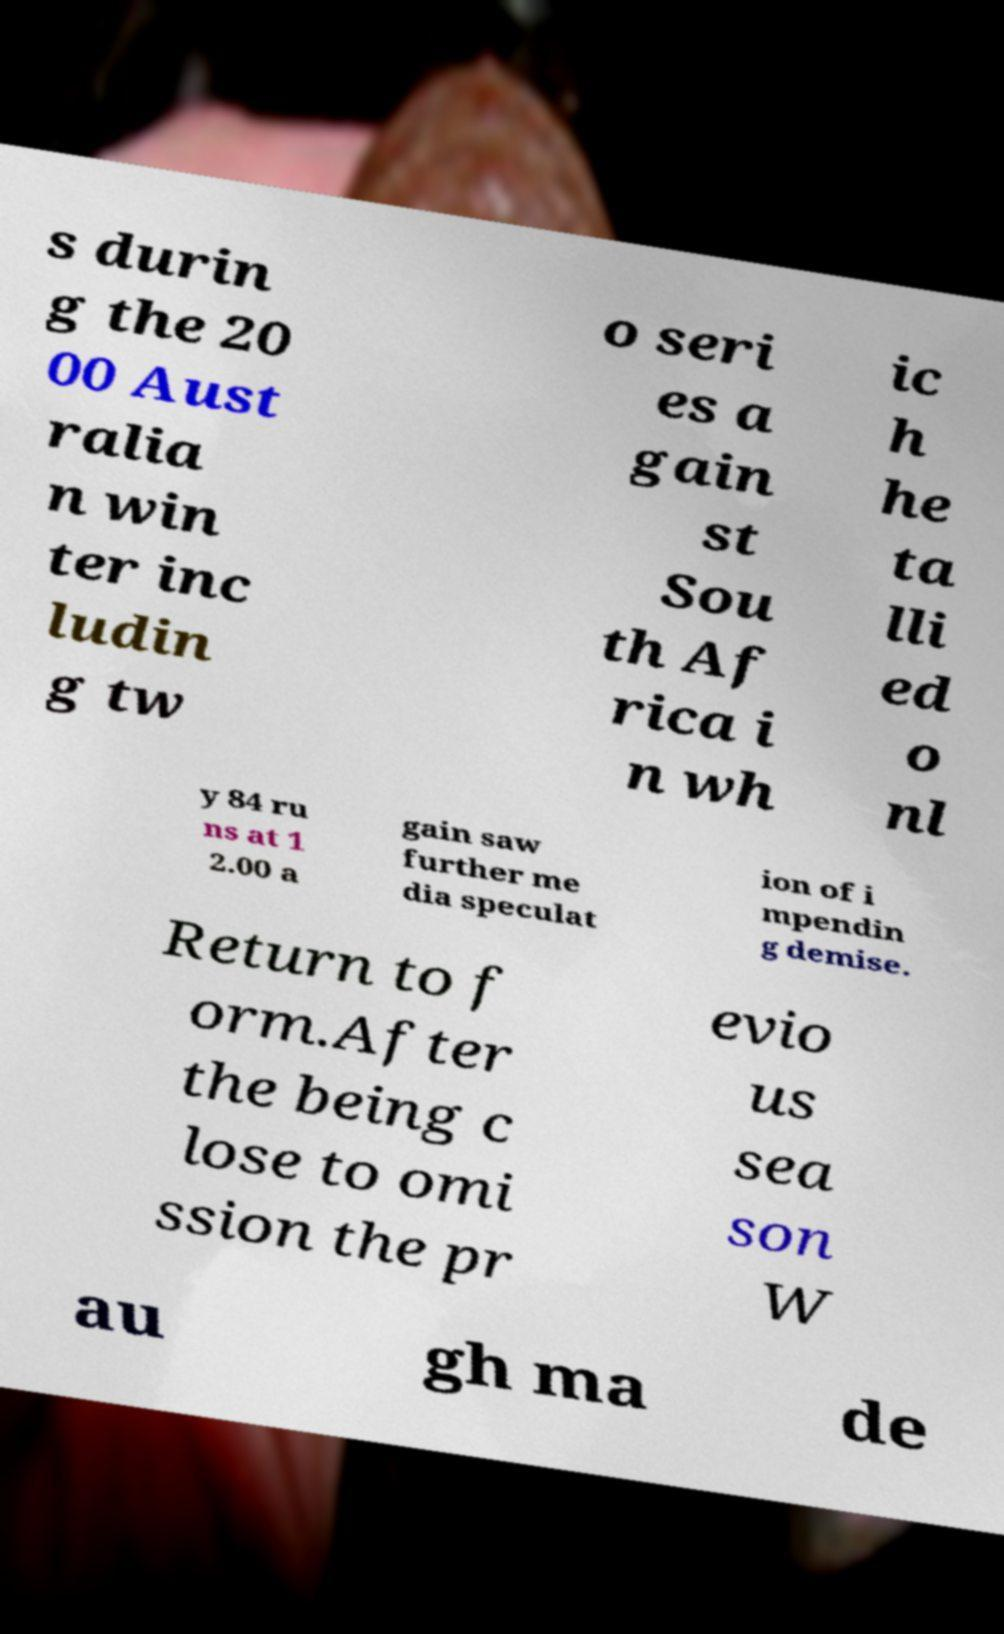There's text embedded in this image that I need extracted. Can you transcribe it verbatim? s durin g the 20 00 Aust ralia n win ter inc ludin g tw o seri es a gain st Sou th Af rica i n wh ic h he ta lli ed o nl y 84 ru ns at 1 2.00 a gain saw further me dia speculat ion of i mpendin g demise. Return to f orm.After the being c lose to omi ssion the pr evio us sea son W au gh ma de 